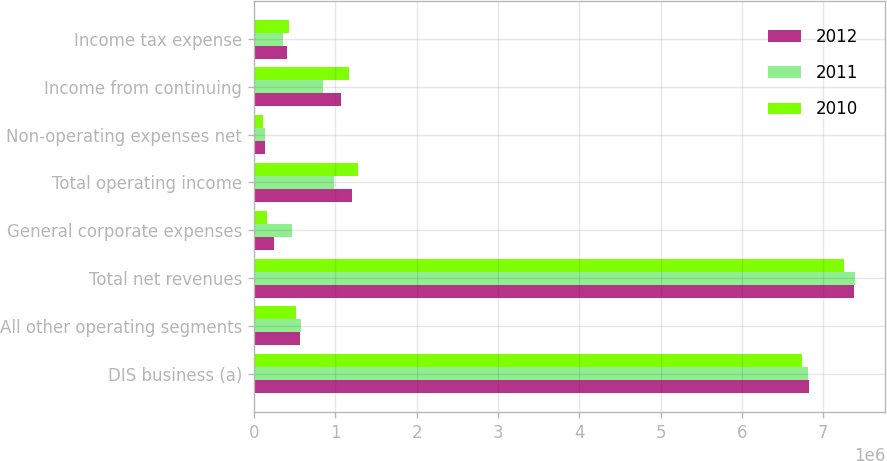Convert chart to OTSL. <chart><loc_0><loc_0><loc_500><loc_500><stacked_bar_chart><ecel><fcel>DIS business (a)<fcel>All other operating segments<fcel>Total net revenues<fcel>General corporate expenses<fcel>Total operating income<fcel>Non-operating expenses net<fcel>Income from continuing<fcel>Income tax expense<nl><fcel>2012<fcel>6.81992e+06<fcel>562646<fcel>7.38256e+06<fcel>242113<fcel>1.2008e+06<fcel>132402<fcel>1.0684e+06<fcel>401897<nl><fcel>2011<fcel>6.81172e+06<fcel>580210<fcel>7.39193e+06<fcel>471628<fcel>986641<fcel>137847<fcel>848794<fcel>354702<nl><fcel>2010<fcel>6.73684e+06<fcel>523280<fcel>7.26012e+06<fcel>166844<fcel>1.28358e+06<fcel>108599<fcel>1.17498e+06<fcel>430127<nl></chart> 